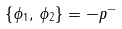Convert formula to latex. <formula><loc_0><loc_0><loc_500><loc_500>\left \{ \phi _ { 1 } , \, \phi _ { 2 } \right \} = - p ^ { - }</formula> 